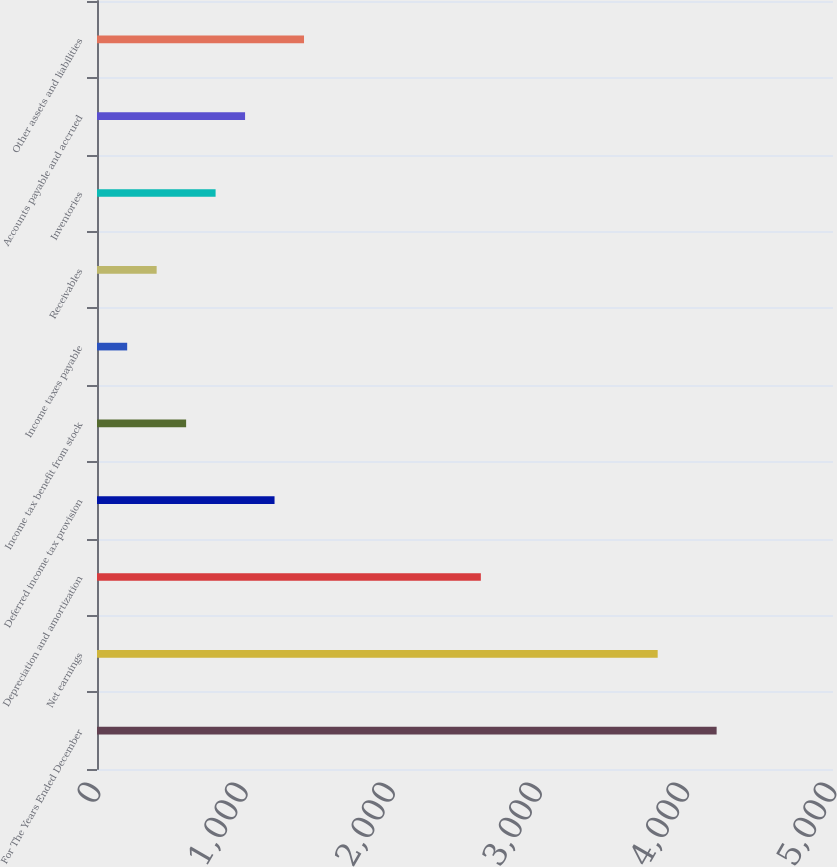<chart> <loc_0><loc_0><loc_500><loc_500><bar_chart><fcel>For The Years Ended December<fcel>Net earnings<fcel>Depreciation and amortization<fcel>Deferred income tax provision<fcel>Income tax benefit from stock<fcel>Income taxes payable<fcel>Receivables<fcel>Inventories<fcel>Accounts payable and accrued<fcel>Other assets and liabilities<nl><fcel>4209.42<fcel>3808.98<fcel>2607.66<fcel>1206.12<fcel>605.46<fcel>205.02<fcel>405.24<fcel>805.68<fcel>1005.9<fcel>1406.34<nl></chart> 